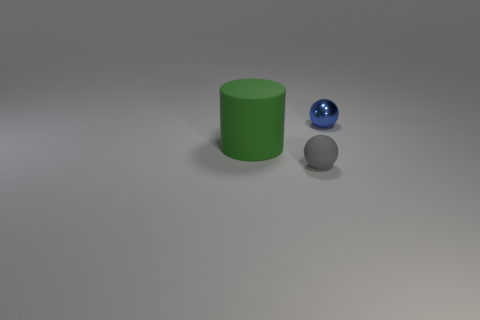Add 2 matte things. How many objects exist? 5 Subtract 1 cylinders. How many cylinders are left? 0 Subtract all blue balls. How many balls are left? 1 Subtract all blue spheres. How many cyan cylinders are left? 0 Add 2 large objects. How many large objects exist? 3 Subtract 1 blue spheres. How many objects are left? 2 Subtract all cylinders. How many objects are left? 2 Subtract all yellow cylinders. Subtract all red blocks. How many cylinders are left? 1 Subtract all large green rubber cylinders. Subtract all large cylinders. How many objects are left? 1 Add 1 small matte spheres. How many small matte spheres are left? 2 